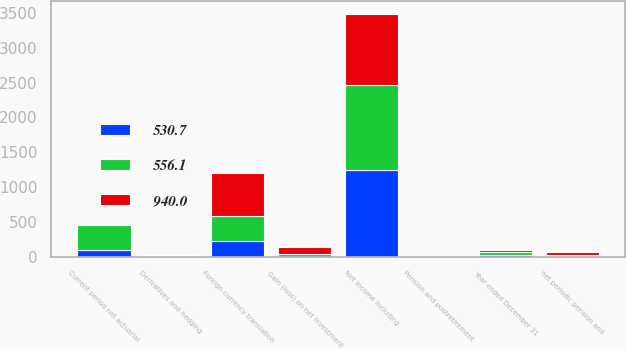<chart> <loc_0><loc_0><loc_500><loc_500><stacked_bar_chart><ecel><fcel>Year ended December 31<fcel>Net income including<fcel>Foreign currency translation<fcel>Gain (loss) on net investment<fcel>Derivatives and hedging<fcel>Current period net actuarial<fcel>Pension and postretirement<fcel>net periodic pension and<nl><fcel>530.7<fcel>33.6<fcel>1247.1<fcel>230.4<fcel>2.5<fcel>17.5<fcel>102.3<fcel>7.7<fcel>20.2<nl><fcel>940<fcel>33.6<fcel>1017.2<fcel>626.8<fcel>101.3<fcel>11.7<fcel>2.3<fcel>4.5<fcel>33.6<nl><fcel>556.1<fcel>33.6<fcel>1222.2<fcel>350.3<fcel>34.7<fcel>3.9<fcel>354.8<fcel>0.6<fcel>12.1<nl></chart> 